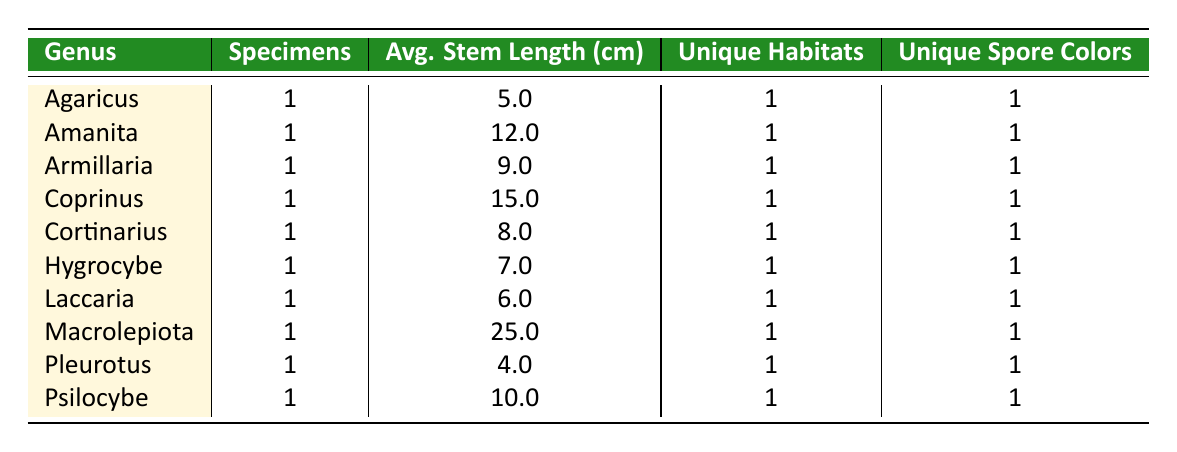What's the average stem length for the genus Amanita? The table shows that there is one specimen of Amanita with a stem length of 12 cm. Since there is only one specimen, the average is simply 12 cm.
Answer: 12 How many unique habitats are reported for the genus Psilocybe? There is one specimen of Psilocybe listed in the table, which indicates that it was found in one unique habitat, specifically a cattle pasture.
Answer: 1 What is the spore print color of the specimen under the genus Macrolepiota? According to the table, the specimen classified as Macrolepiota has a spore print color listed as white.
Answer: White Which genus has the longest average stem length, and what is that length? By reviewing the table, Macrolepiota has an average stem length of 25 cm, which is greater than any other genus.
Answer: Macrolepiota, 25 cm Do all genera in the table have a unique spore color? Yes, each genus listed in the table has a unique spore color for its respective specimen based on the provided data.
Answer: Yes What is the total number of specimens represented in the table? The table lists a total of 10 specimens across different genera, each specified in separate rows.
Answer: 10 Is there any genus that has a stem length less than 6 cm? The genus Pleurotus has a stem length of 4 cm, which is less than 6 cm, confirming that there is at least one such genus.
Answer: Yes Which genus was collected in an oak forest habitat, and how many specimens does it have? The genus Cortinarius is shown to have one specimen recorded in the oak forest habitat in Jalisco, as indicated in the table.
Answer: Cortinarius, 1 specimen What is the average stem length of all the specimens in the table? To calculate the average, we sum up all the stem lengths: 5 + 12 + 10 + 6 + 8 + 25 + 15 + 4 + 7 + 9 = 97. There are 10 specimens, so the average is 97/10 = 9.7 cm.
Answer: 9.7 cm 